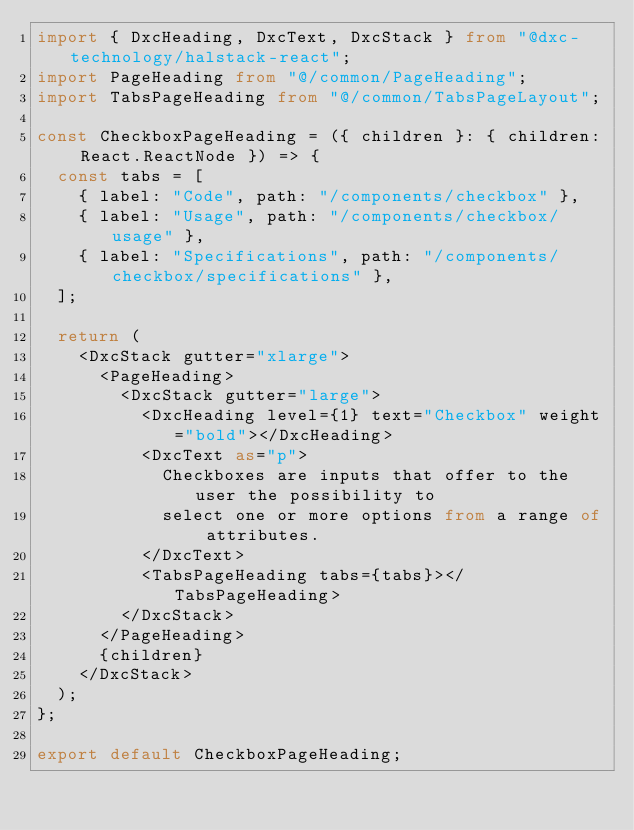Convert code to text. <code><loc_0><loc_0><loc_500><loc_500><_TypeScript_>import { DxcHeading, DxcText, DxcStack } from "@dxc-technology/halstack-react";
import PageHeading from "@/common/PageHeading";
import TabsPageHeading from "@/common/TabsPageLayout";

const CheckboxPageHeading = ({ children }: { children: React.ReactNode }) => {
  const tabs = [
    { label: "Code", path: "/components/checkbox" },
    { label: "Usage", path: "/components/checkbox/usage" },
    { label: "Specifications", path: "/components/checkbox/specifications" },
  ];

  return (
    <DxcStack gutter="xlarge">
      <PageHeading>
        <DxcStack gutter="large">
          <DxcHeading level={1} text="Checkbox" weight="bold"></DxcHeading>
          <DxcText as="p">
            Checkboxes are inputs that offer to the user the possibility to
            select one or more options from a range of attributes.
          </DxcText>
          <TabsPageHeading tabs={tabs}></TabsPageHeading>
        </DxcStack>
      </PageHeading>
      {children}
    </DxcStack>
  );
};

export default CheckboxPageHeading;
</code> 